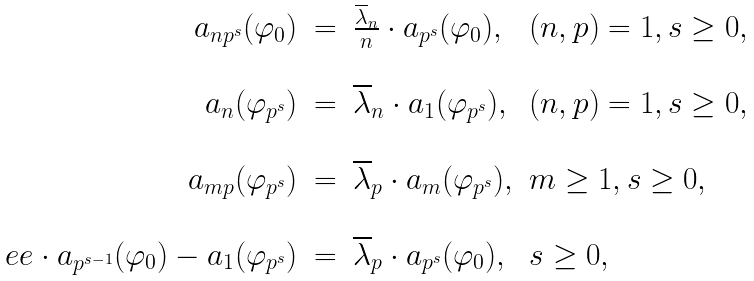Convert formula to latex. <formula><loc_0><loc_0><loc_500><loc_500>\begin{array} { r c l l } a _ { n p ^ { s } } ( \varphi _ { 0 } ) & = & \frac { \overline { \lambda } _ { n } } { n } \cdot a _ { p ^ { s } } ( \varphi _ { 0 } ) , & ( n , p ) = 1 , s \geq 0 , \\ \ & \ & \ & \ \\ a _ { n } ( \varphi _ { p ^ { s } } ) & = & \overline { \lambda } _ { n } \cdot a _ { 1 } ( \varphi _ { p ^ { s } } ) , & ( n , p ) = 1 , s \geq 0 , \\ \ & \ & \ & \ \\ a _ { m p } ( \varphi _ { p ^ { s } } ) & = & \overline { \lambda } _ { p } \cdot a _ { m } ( \varphi _ { p ^ { s } } ) , & m \geq 1 , s \geq 0 , \\ \ & \ & \ & \ \\ \ e e \cdot a _ { p ^ { s - 1 } } ( \varphi _ { 0 } ) - a _ { 1 } ( \varphi _ { p ^ { s } } ) & = & \overline { \lambda } _ { p } \cdot a _ { p ^ { s } } ( \varphi _ { 0 } ) , & s \geq 0 , \end{array}</formula> 